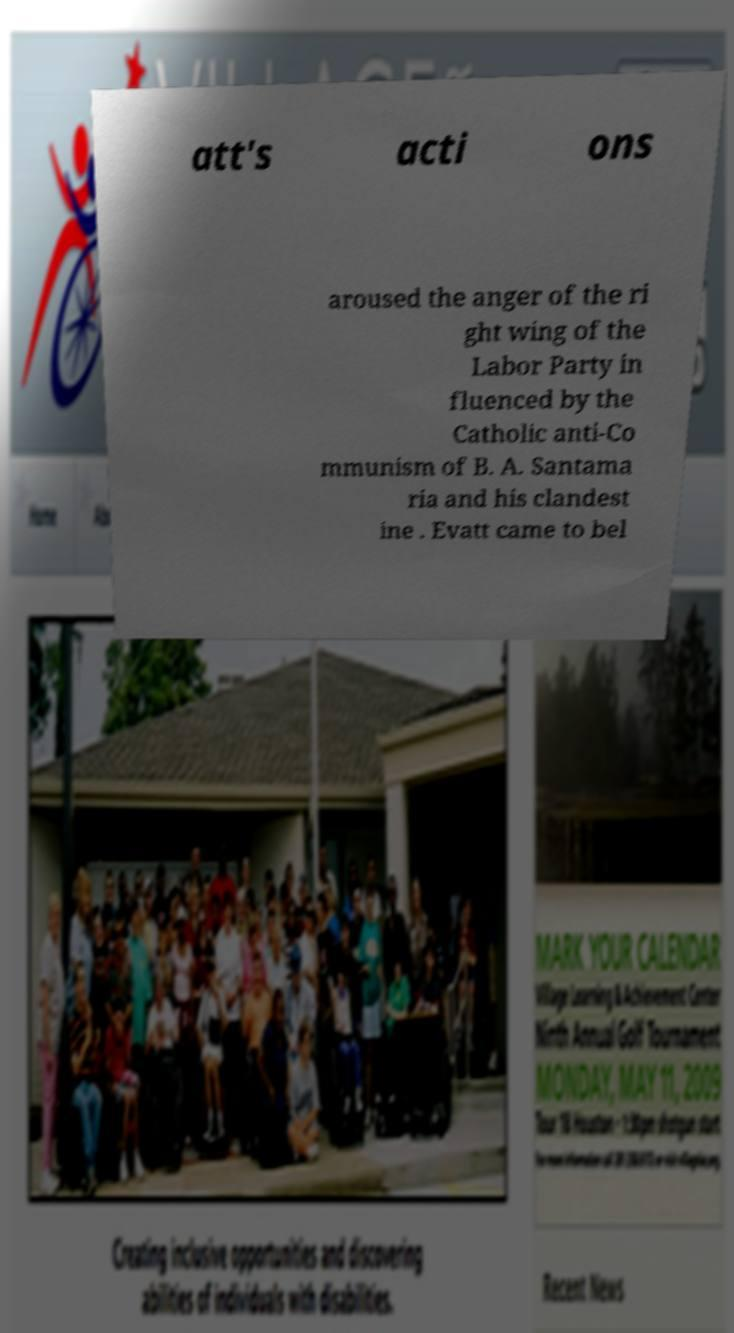I need the written content from this picture converted into text. Can you do that? att's acti ons aroused the anger of the ri ght wing of the Labor Party in fluenced by the Catholic anti-Co mmunism of B. A. Santama ria and his clandest ine . Evatt came to bel 